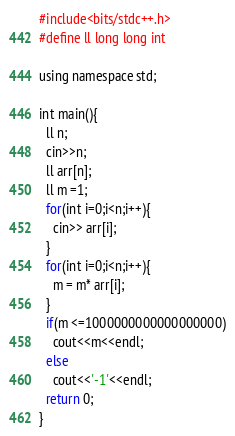Convert code to text. <code><loc_0><loc_0><loc_500><loc_500><_Python_>#include<bits/stdc++.h>
#define ll long long int
 
using namespace std;
 
int main(){
  ll n;
  cin>>n;
  ll arr[n];
  ll m =1;
  for(int i=0;i<n;i++){
    cin>> arr[i];
  }
  for(int i=0;i<n;i++){
    m = m* arr[i];
  }
  if(m <=1000000000000000000)
    cout<<m<<endl;
  else
    cout<<'-1'<<endl;
  return 0;
}</code> 